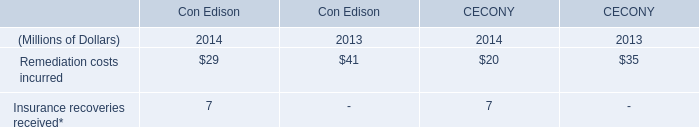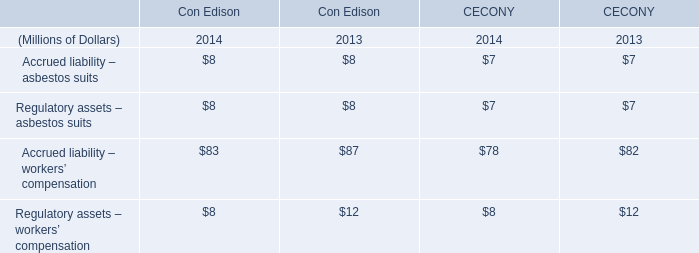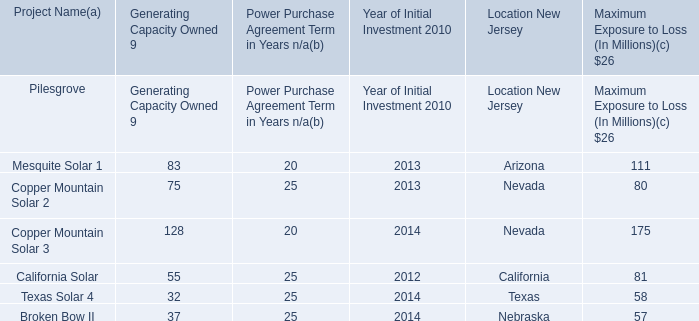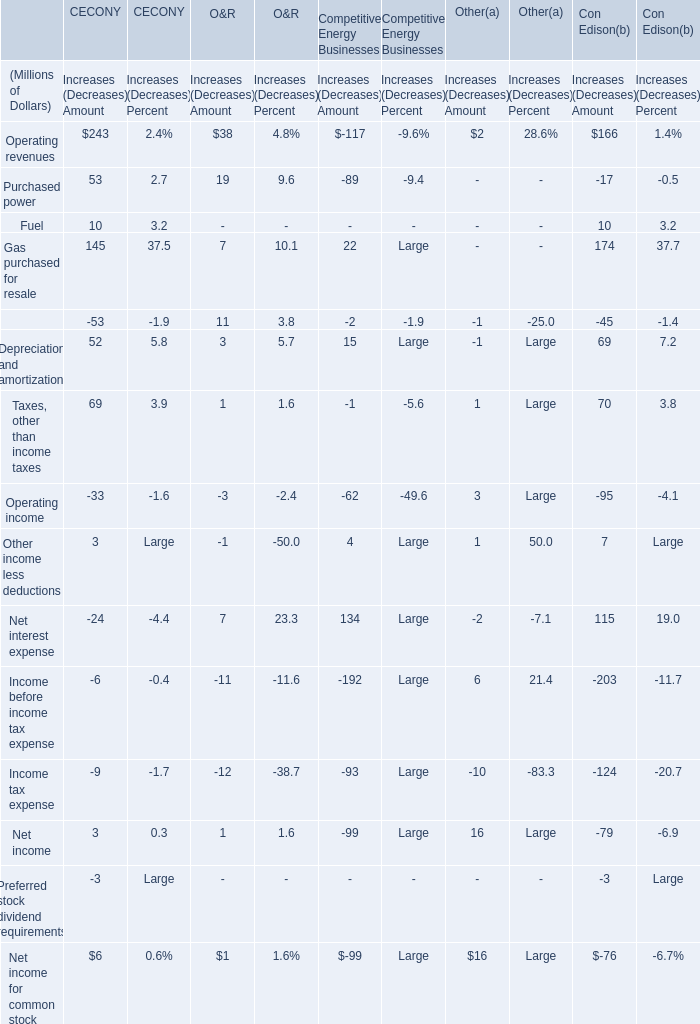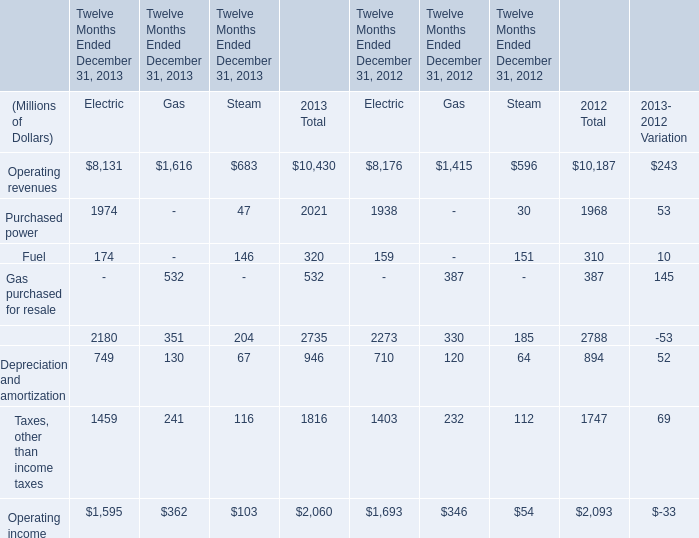What's the total value of all Increases (Decreases) Amount that are smaller than 200 in Operating revenues? (in Millions of Dollars) 
Computations: (((38 - 117) + 2) + 166)
Answer: 89.0. When does operating income of electric reach the largest value? 
Answer: 2012. 